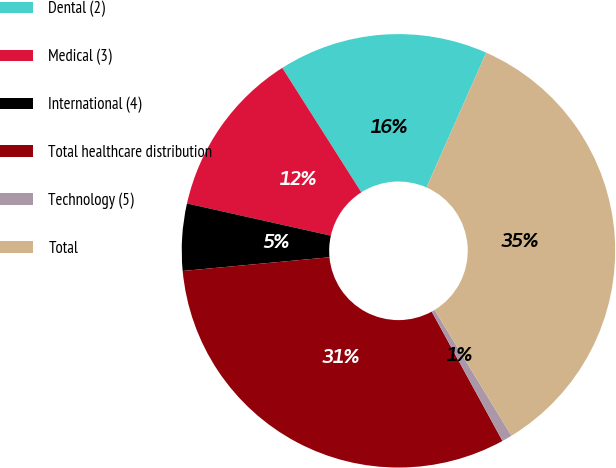Convert chart. <chart><loc_0><loc_0><loc_500><loc_500><pie_chart><fcel>Dental (2)<fcel>Medical (3)<fcel>International (4)<fcel>Total healthcare distribution<fcel>Technology (5)<fcel>Total<nl><fcel>15.64%<fcel>12.49%<fcel>4.99%<fcel>31.49%<fcel>0.76%<fcel>34.64%<nl></chart> 